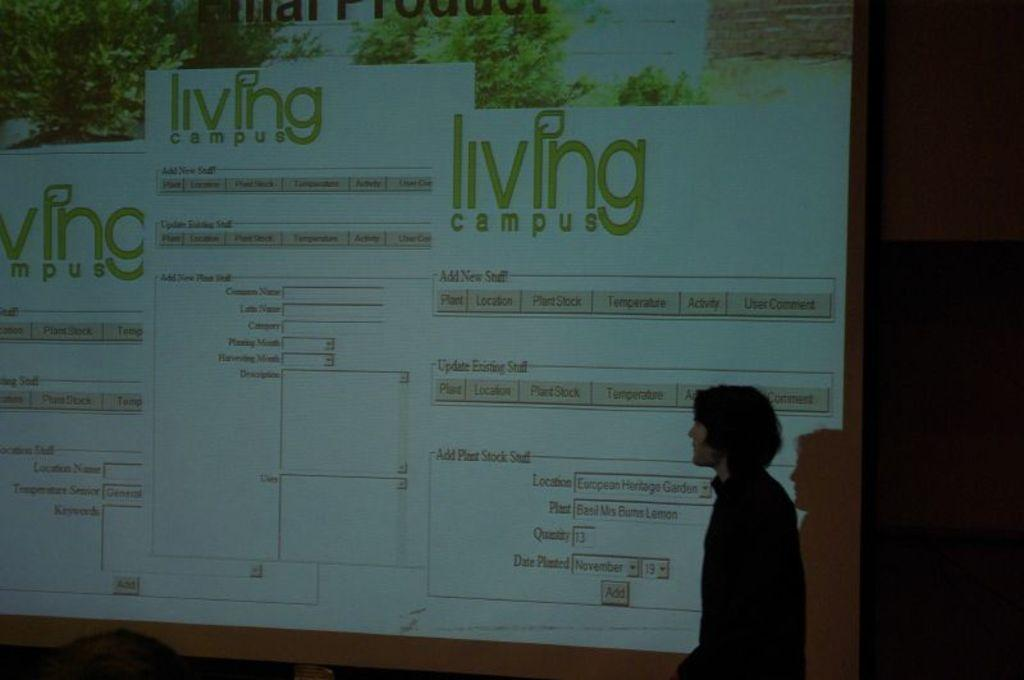<image>
Present a compact description of the photo's key features. a presentation with the words living campus on it 